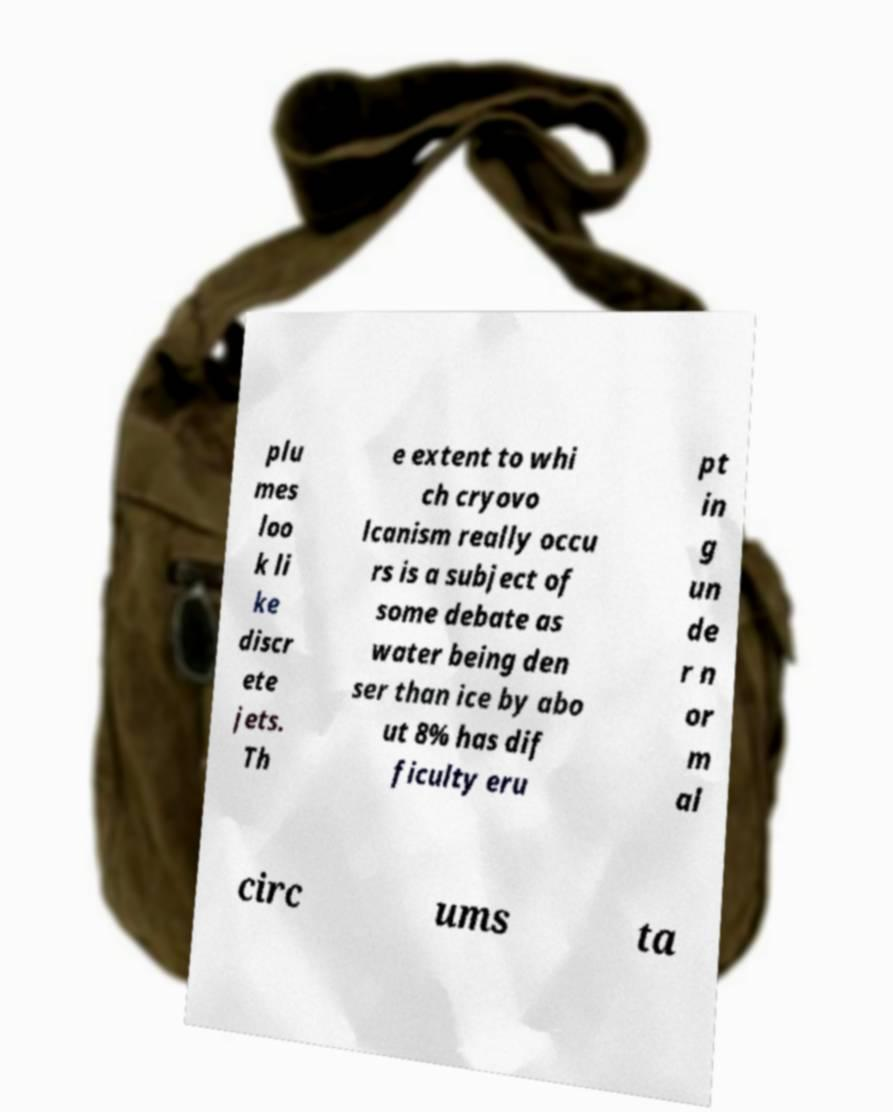Please read and relay the text visible in this image. What does it say? plu mes loo k li ke discr ete jets. Th e extent to whi ch cryovo lcanism really occu rs is a subject of some debate as water being den ser than ice by abo ut 8% has dif ficulty eru pt in g un de r n or m al circ ums ta 